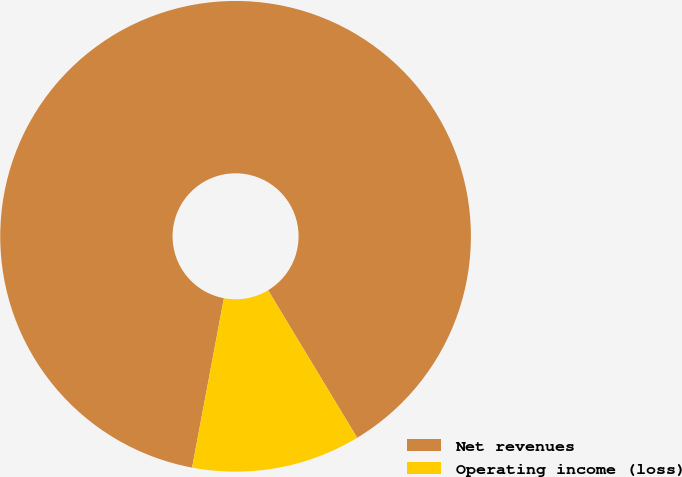Convert chart. <chart><loc_0><loc_0><loc_500><loc_500><pie_chart><fcel>Net revenues<fcel>Operating income (loss)<nl><fcel>88.4%<fcel>11.6%<nl></chart> 